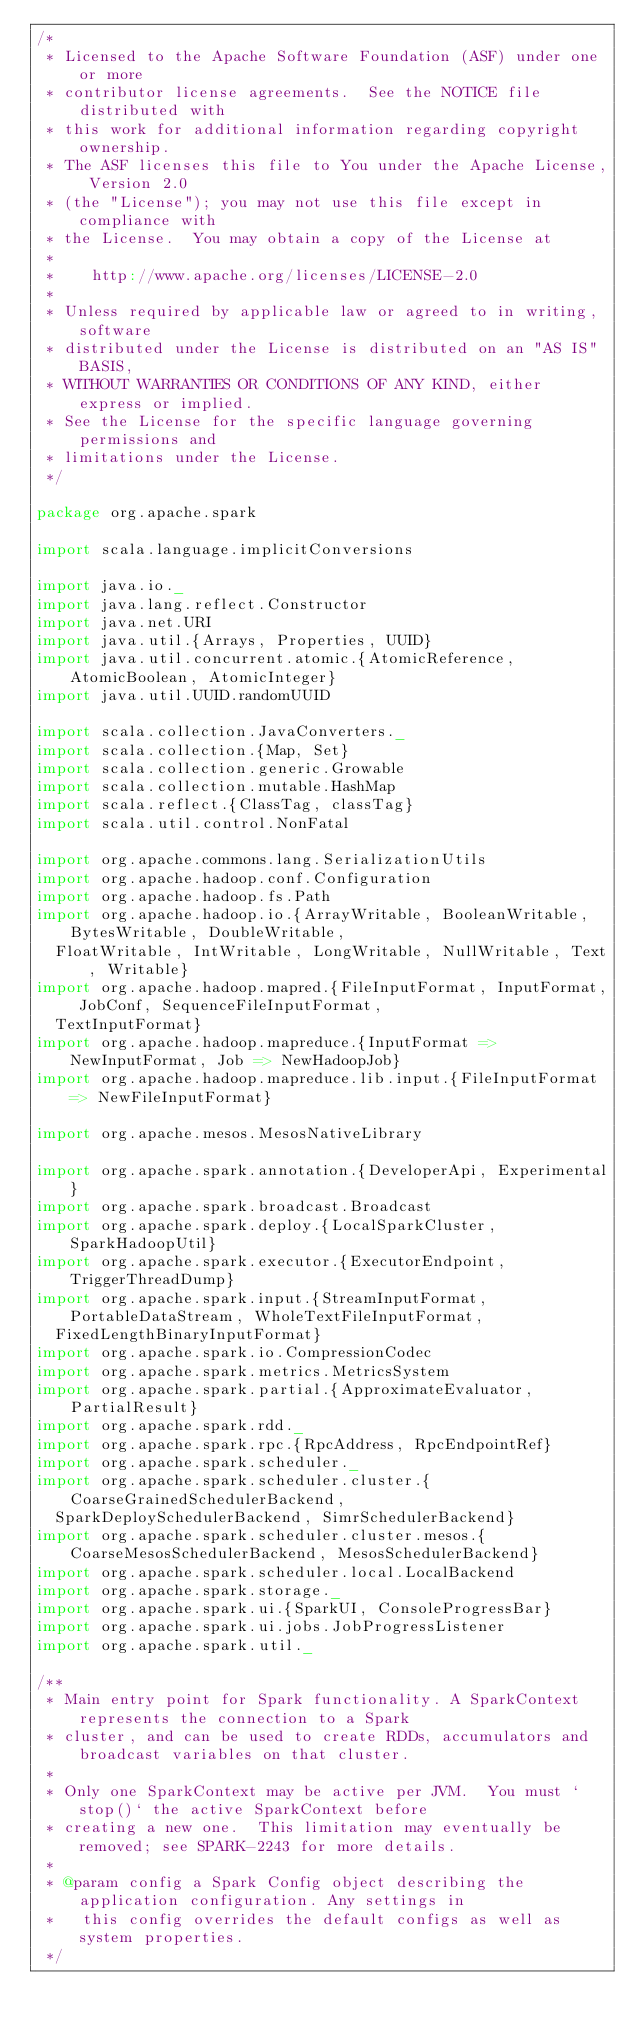Convert code to text. <code><loc_0><loc_0><loc_500><loc_500><_Scala_>/*
 * Licensed to the Apache Software Foundation (ASF) under one or more
 * contributor license agreements.  See the NOTICE file distributed with
 * this work for additional information regarding copyright ownership.
 * The ASF licenses this file to You under the Apache License, Version 2.0
 * (the "License"); you may not use this file except in compliance with
 * the License.  You may obtain a copy of the License at
 *
 *    http://www.apache.org/licenses/LICENSE-2.0
 *
 * Unless required by applicable law or agreed to in writing, software
 * distributed under the License is distributed on an "AS IS" BASIS,
 * WITHOUT WARRANTIES OR CONDITIONS OF ANY KIND, either express or implied.
 * See the License for the specific language governing permissions and
 * limitations under the License.
 */

package org.apache.spark

import scala.language.implicitConversions

import java.io._
import java.lang.reflect.Constructor
import java.net.URI
import java.util.{Arrays, Properties, UUID}
import java.util.concurrent.atomic.{AtomicReference, AtomicBoolean, AtomicInteger}
import java.util.UUID.randomUUID

import scala.collection.JavaConverters._
import scala.collection.{Map, Set}
import scala.collection.generic.Growable
import scala.collection.mutable.HashMap
import scala.reflect.{ClassTag, classTag}
import scala.util.control.NonFatal

import org.apache.commons.lang.SerializationUtils
import org.apache.hadoop.conf.Configuration
import org.apache.hadoop.fs.Path
import org.apache.hadoop.io.{ArrayWritable, BooleanWritable, BytesWritable, DoubleWritable,
  FloatWritable, IntWritable, LongWritable, NullWritable, Text, Writable}
import org.apache.hadoop.mapred.{FileInputFormat, InputFormat, JobConf, SequenceFileInputFormat,
  TextInputFormat}
import org.apache.hadoop.mapreduce.{InputFormat => NewInputFormat, Job => NewHadoopJob}
import org.apache.hadoop.mapreduce.lib.input.{FileInputFormat => NewFileInputFormat}

import org.apache.mesos.MesosNativeLibrary

import org.apache.spark.annotation.{DeveloperApi, Experimental}
import org.apache.spark.broadcast.Broadcast
import org.apache.spark.deploy.{LocalSparkCluster, SparkHadoopUtil}
import org.apache.spark.executor.{ExecutorEndpoint, TriggerThreadDump}
import org.apache.spark.input.{StreamInputFormat, PortableDataStream, WholeTextFileInputFormat,
  FixedLengthBinaryInputFormat}
import org.apache.spark.io.CompressionCodec
import org.apache.spark.metrics.MetricsSystem
import org.apache.spark.partial.{ApproximateEvaluator, PartialResult}
import org.apache.spark.rdd._
import org.apache.spark.rpc.{RpcAddress, RpcEndpointRef}
import org.apache.spark.scheduler._
import org.apache.spark.scheduler.cluster.{CoarseGrainedSchedulerBackend,
  SparkDeploySchedulerBackend, SimrSchedulerBackend}
import org.apache.spark.scheduler.cluster.mesos.{CoarseMesosSchedulerBackend, MesosSchedulerBackend}
import org.apache.spark.scheduler.local.LocalBackend
import org.apache.spark.storage._
import org.apache.spark.ui.{SparkUI, ConsoleProgressBar}
import org.apache.spark.ui.jobs.JobProgressListener
import org.apache.spark.util._

/**
 * Main entry point for Spark functionality. A SparkContext represents the connection to a Spark
 * cluster, and can be used to create RDDs, accumulators and broadcast variables on that cluster.
 *
 * Only one SparkContext may be active per JVM.  You must `stop()` the active SparkContext before
 * creating a new one.  This limitation may eventually be removed; see SPARK-2243 for more details.
 *
 * @param config a Spark Config object describing the application configuration. Any settings in
 *   this config overrides the default configs as well as system properties.
 */</code> 